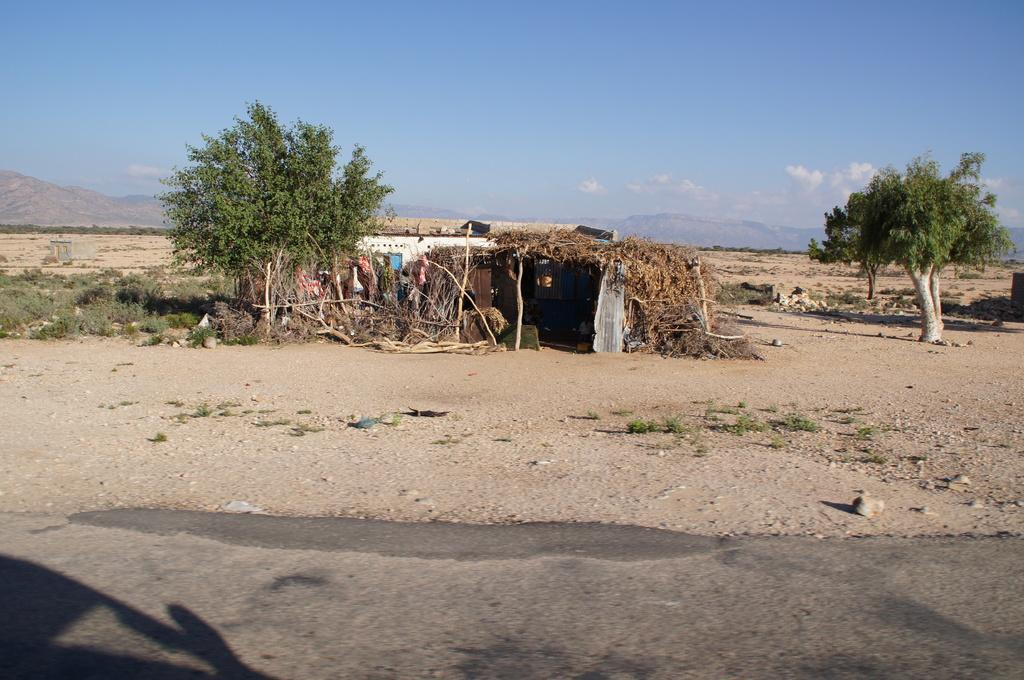What type of vegetation can be seen in the image? There are trees and plants in the image. What geographical features are present in the image? There are hills in the image. What type of structures can be seen in the image? There is a hut and a house in the image. How would you describe the sky in the image? The sky is blue and cloudy in the image. How many sheep are visible in the image? There are no sheep present in the image. What type of boot is being worn by the tree in the image? There are no boots present in the image, as trees are not capable of wearing footwear. 